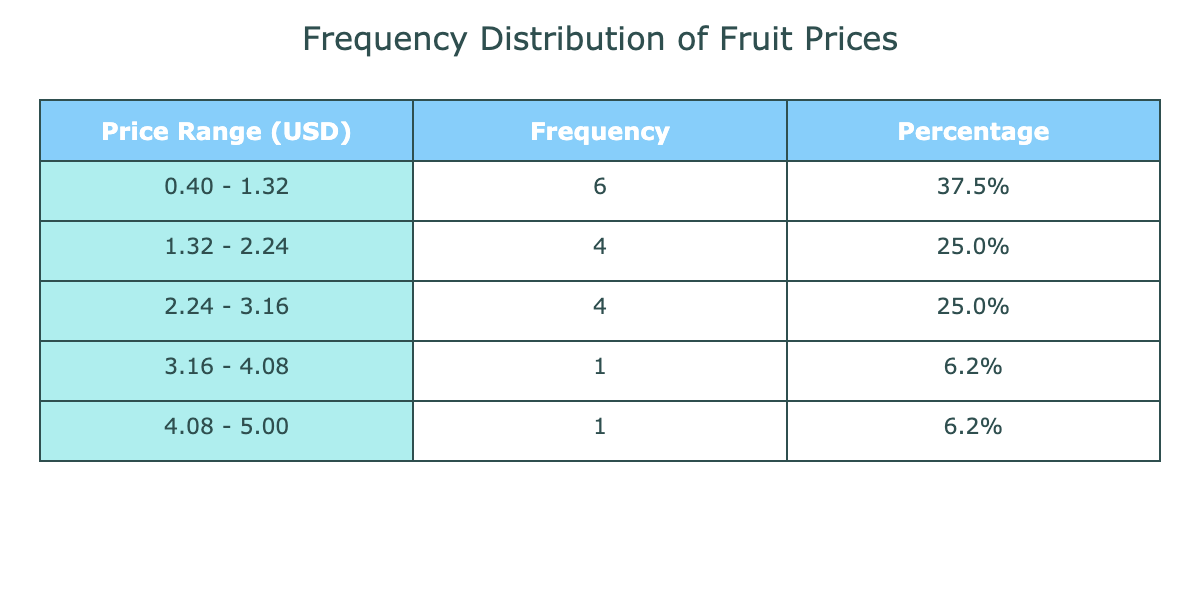What is the frequency of fruit prices in the range of 1.00 to 2.00 USD? By checking the frequency distribution table, we can see the price range of 1.00 to 2.00 USD corresponds to the frequency value listed next to that price interval. In this case, the frequency for that range is counted, which is 5.
Answer: 5 What percentage of fruits fall in the price range of 3.00 to 4.00 USD? Referring to the table, the frequency for the price range of 3.00 to 4.00 USD is 3. To find the percentage, divide the frequency (3) by the total number of fruits (15), then multiply by 100, resulting in (3/15)*100 = 20.0%.
Answer: 20.0% Is the frequency of fruits priced at 0.40 to 1.00 USD greater than that priced at 2.00 to 3.00 USD? From the table, the frequency for the price range of 0.40 to 1.00 USD is 4, while the frequency for the range of 2.00 to 3.00 USD is 5. Since 4 is not greater than 5, the statement is false.
Answer: No What is the total number of fruits that are priced below 2.00 USD? By examining the price ranges below 2.00 USD in the table, we sum the frequencies from the ranges of 0.40 to 1.00 USD (4) and 1.00 to 2.00 USD (5). The total number of fruits priced below 2.00 USD is 4 + 5 = 9.
Answer: 9 What is the average price of fruits in the range of 2.00 to 3.00 USD? The price range of 2.00 to 3.00 USD contains the fruits with prices: 2.00, 2.20, 2.50, and 2.80. To find the average, add these prices (2.00 + 2.20 + 2.50 + 2.80 = 9.50) and divide by the number of fruits in this range (4). Therefore, the average price is 9.50 / 4 = 2.375.
Answer: 2.375 How many fruit suppliers offer fruits priced above 4.00 USD? Looking at the table, the price range above 4.00 USD is only represented by the Dragon Fruit from Exotic Fruits Ltd., which has a price of 5.00. Since there is only one supplier that fits this criterion, the total is 1.
Answer: 1 